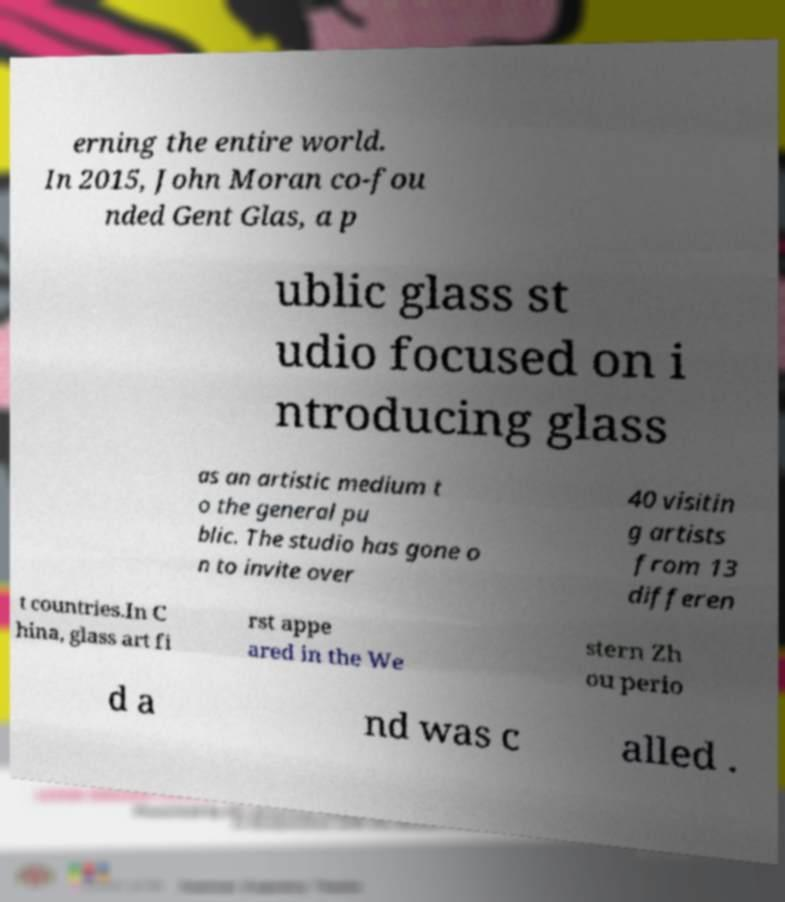Could you assist in decoding the text presented in this image and type it out clearly? erning the entire world. In 2015, John Moran co-fou nded Gent Glas, a p ublic glass st udio focused on i ntroducing glass as an artistic medium t o the general pu blic. The studio has gone o n to invite over 40 visitin g artists from 13 differen t countries.In C hina, glass art fi rst appe ared in the We stern Zh ou perio d a nd was c alled . 